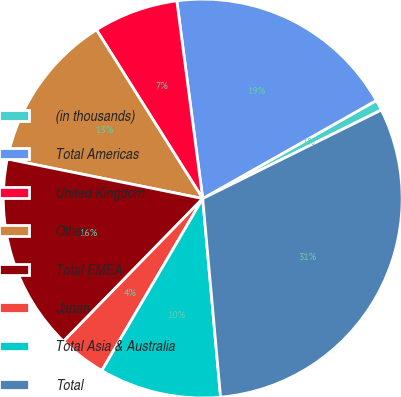Convert chart to OTSL. <chart><loc_0><loc_0><loc_500><loc_500><pie_chart><fcel>(in thousands)<fcel>Total Americas<fcel>United Kingdom<fcel>Other<fcel>Total EMEA<fcel>Japan<fcel>Total Asia & Australia<fcel>Total<nl><fcel>0.86%<fcel>18.89%<fcel>6.87%<fcel>12.88%<fcel>15.88%<fcel>3.86%<fcel>9.87%<fcel>30.9%<nl></chart> 